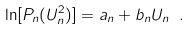Convert formula to latex. <formula><loc_0><loc_0><loc_500><loc_500>\ln [ P _ { n } ( U _ { n } ^ { 2 } ) ] = a _ { n } + b _ { n } U _ { n } \ .</formula> 